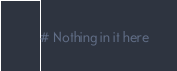<code> <loc_0><loc_0><loc_500><loc_500><_Python_># Nothing in it here
</code> 